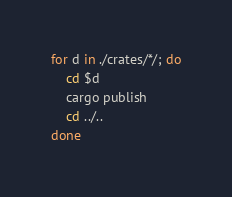<code> <loc_0><loc_0><loc_500><loc_500><_Bash_>for d in ./crates/*/; do
    cd $d
    cargo publish
    cd ../..
done</code> 